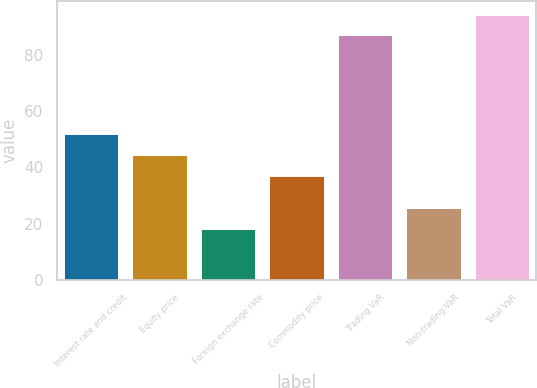Convert chart. <chart><loc_0><loc_0><loc_500><loc_500><bar_chart><fcel>Interest rate and credit<fcel>Equity price<fcel>Foreign exchange rate<fcel>Commodity price<fcel>Trading VaR<fcel>Non-trading VaR<fcel>Total VaR<nl><fcel>51.8<fcel>44.4<fcel>18<fcel>37<fcel>87<fcel>25.4<fcel>94.4<nl></chart> 